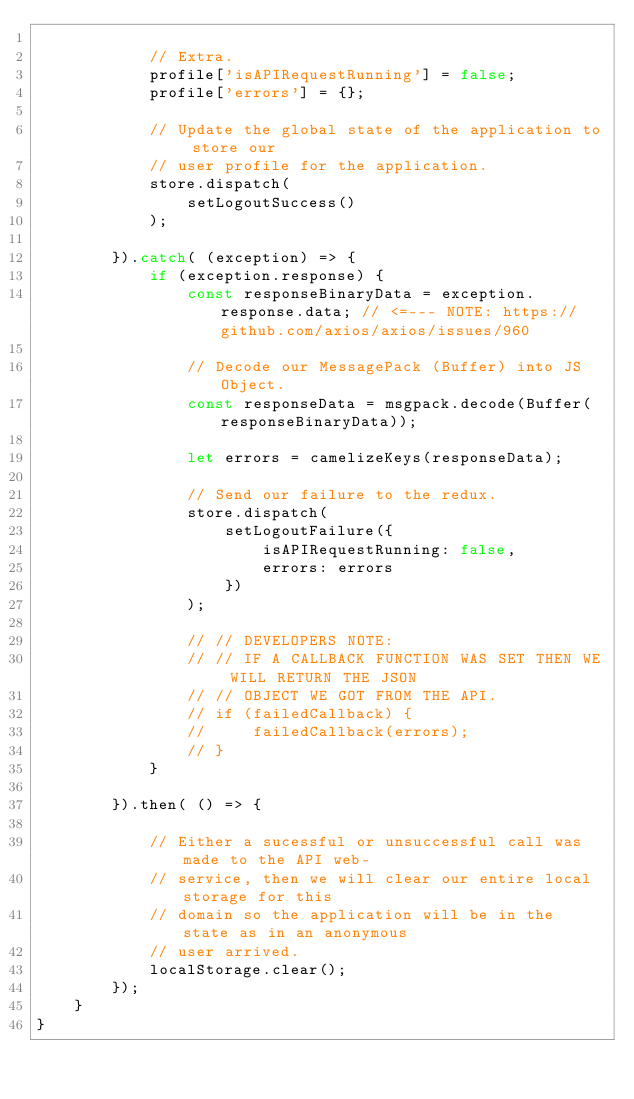<code> <loc_0><loc_0><loc_500><loc_500><_JavaScript_>
            // Extra.
            profile['isAPIRequestRunning'] = false;
            profile['errors'] = {};

            // Update the global state of the application to store our
            // user profile for the application.
            store.dispatch(
                setLogoutSuccess()
            );

        }).catch( (exception) => {
            if (exception.response) {
                const responseBinaryData = exception.response.data; // <=--- NOTE: https://github.com/axios/axios/issues/960

                // Decode our MessagePack (Buffer) into JS Object.
                const responseData = msgpack.decode(Buffer(responseBinaryData));

                let errors = camelizeKeys(responseData);

                // Send our failure to the redux.
                store.dispatch(
                    setLogoutFailure({
                        isAPIRequestRunning: false,
                        errors: errors
                    })
                );

                // // DEVELOPERS NOTE:
                // // IF A CALLBACK FUNCTION WAS SET THEN WE WILL RETURN THE JSON
                // // OBJECT WE GOT FROM THE API.
                // if (failedCallback) {
                //     failedCallback(errors);
                // }
            }

        }).then( () => {

            // Either a sucessful or unsuccessful call was made to the API web-
            // service, then we will clear our entire local storage for this
            // domain so the application will be in the state as in an anonymous
            // user arrived.
            localStorage.clear();
        });
    }
}
</code> 